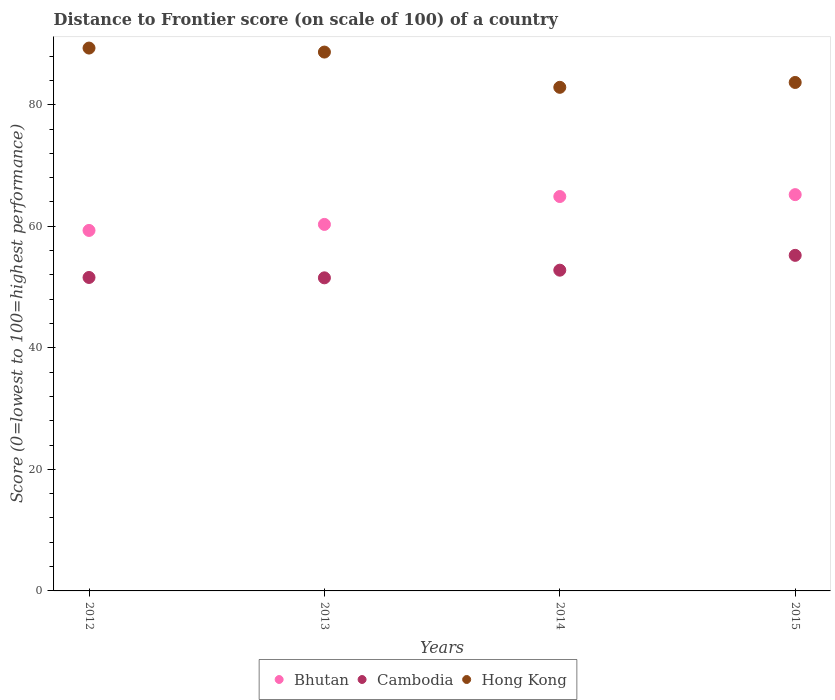Is the number of dotlines equal to the number of legend labels?
Your answer should be very brief. Yes. What is the distance to frontier score of in Bhutan in 2015?
Keep it short and to the point. 65.21. Across all years, what is the maximum distance to frontier score of in Bhutan?
Ensure brevity in your answer.  65.21. Across all years, what is the minimum distance to frontier score of in Hong Kong?
Offer a very short reply. 82.87. In which year was the distance to frontier score of in Hong Kong maximum?
Ensure brevity in your answer.  2012. What is the total distance to frontier score of in Bhutan in the graph?
Ensure brevity in your answer.  249.74. What is the difference between the distance to frontier score of in Cambodia in 2012 and that in 2015?
Provide a succinct answer. -3.64. What is the difference between the distance to frontier score of in Cambodia in 2013 and the distance to frontier score of in Hong Kong in 2012?
Make the answer very short. -37.81. What is the average distance to frontier score of in Bhutan per year?
Ensure brevity in your answer.  62.44. In the year 2014, what is the difference between the distance to frontier score of in Hong Kong and distance to frontier score of in Bhutan?
Provide a succinct answer. 17.97. What is the ratio of the distance to frontier score of in Bhutan in 2014 to that in 2015?
Offer a very short reply. 1. Is the distance to frontier score of in Cambodia in 2014 less than that in 2015?
Your answer should be very brief. Yes. What is the difference between the highest and the second highest distance to frontier score of in Bhutan?
Ensure brevity in your answer.  0.31. What is the difference between the highest and the lowest distance to frontier score of in Cambodia?
Make the answer very short. 3.7. In how many years, is the distance to frontier score of in Cambodia greater than the average distance to frontier score of in Cambodia taken over all years?
Your response must be concise. 2. Does the distance to frontier score of in Bhutan monotonically increase over the years?
Your answer should be compact. Yes. How many years are there in the graph?
Give a very brief answer. 4. What is the difference between two consecutive major ticks on the Y-axis?
Offer a terse response. 20. Does the graph contain any zero values?
Give a very brief answer. No. How many legend labels are there?
Your answer should be compact. 3. How are the legend labels stacked?
Provide a short and direct response. Horizontal. What is the title of the graph?
Provide a short and direct response. Distance to Frontier score (on scale of 100) of a country. What is the label or title of the Y-axis?
Offer a very short reply. Score (0=lowest to 100=highest performance). What is the Score (0=lowest to 100=highest performance) of Bhutan in 2012?
Provide a succinct answer. 59.32. What is the Score (0=lowest to 100=highest performance) in Cambodia in 2012?
Make the answer very short. 51.58. What is the Score (0=lowest to 100=highest performance) in Hong Kong in 2012?
Your response must be concise. 89.33. What is the Score (0=lowest to 100=highest performance) in Bhutan in 2013?
Your response must be concise. 60.31. What is the Score (0=lowest to 100=highest performance) of Cambodia in 2013?
Make the answer very short. 51.52. What is the Score (0=lowest to 100=highest performance) in Hong Kong in 2013?
Make the answer very short. 88.67. What is the Score (0=lowest to 100=highest performance) in Bhutan in 2014?
Your response must be concise. 64.9. What is the Score (0=lowest to 100=highest performance) in Cambodia in 2014?
Your answer should be very brief. 52.78. What is the Score (0=lowest to 100=highest performance) in Hong Kong in 2014?
Your answer should be very brief. 82.87. What is the Score (0=lowest to 100=highest performance) of Bhutan in 2015?
Provide a succinct answer. 65.21. What is the Score (0=lowest to 100=highest performance) in Cambodia in 2015?
Offer a terse response. 55.22. What is the Score (0=lowest to 100=highest performance) of Hong Kong in 2015?
Your answer should be compact. 83.67. Across all years, what is the maximum Score (0=lowest to 100=highest performance) of Bhutan?
Offer a terse response. 65.21. Across all years, what is the maximum Score (0=lowest to 100=highest performance) of Cambodia?
Make the answer very short. 55.22. Across all years, what is the maximum Score (0=lowest to 100=highest performance) of Hong Kong?
Offer a terse response. 89.33. Across all years, what is the minimum Score (0=lowest to 100=highest performance) of Bhutan?
Keep it short and to the point. 59.32. Across all years, what is the minimum Score (0=lowest to 100=highest performance) of Cambodia?
Ensure brevity in your answer.  51.52. Across all years, what is the minimum Score (0=lowest to 100=highest performance) in Hong Kong?
Your response must be concise. 82.87. What is the total Score (0=lowest to 100=highest performance) of Bhutan in the graph?
Provide a short and direct response. 249.74. What is the total Score (0=lowest to 100=highest performance) of Cambodia in the graph?
Ensure brevity in your answer.  211.1. What is the total Score (0=lowest to 100=highest performance) in Hong Kong in the graph?
Offer a very short reply. 344.54. What is the difference between the Score (0=lowest to 100=highest performance) of Bhutan in 2012 and that in 2013?
Offer a terse response. -0.99. What is the difference between the Score (0=lowest to 100=highest performance) of Hong Kong in 2012 and that in 2013?
Ensure brevity in your answer.  0.66. What is the difference between the Score (0=lowest to 100=highest performance) in Bhutan in 2012 and that in 2014?
Your answer should be compact. -5.58. What is the difference between the Score (0=lowest to 100=highest performance) of Hong Kong in 2012 and that in 2014?
Ensure brevity in your answer.  6.46. What is the difference between the Score (0=lowest to 100=highest performance) of Bhutan in 2012 and that in 2015?
Provide a succinct answer. -5.89. What is the difference between the Score (0=lowest to 100=highest performance) of Cambodia in 2012 and that in 2015?
Give a very brief answer. -3.64. What is the difference between the Score (0=lowest to 100=highest performance) in Hong Kong in 2012 and that in 2015?
Your answer should be compact. 5.66. What is the difference between the Score (0=lowest to 100=highest performance) in Bhutan in 2013 and that in 2014?
Your answer should be very brief. -4.59. What is the difference between the Score (0=lowest to 100=highest performance) of Cambodia in 2013 and that in 2014?
Offer a terse response. -1.26. What is the difference between the Score (0=lowest to 100=highest performance) in Cambodia in 2013 and that in 2015?
Keep it short and to the point. -3.7. What is the difference between the Score (0=lowest to 100=highest performance) of Bhutan in 2014 and that in 2015?
Provide a short and direct response. -0.31. What is the difference between the Score (0=lowest to 100=highest performance) of Cambodia in 2014 and that in 2015?
Offer a terse response. -2.44. What is the difference between the Score (0=lowest to 100=highest performance) in Hong Kong in 2014 and that in 2015?
Provide a short and direct response. -0.8. What is the difference between the Score (0=lowest to 100=highest performance) in Bhutan in 2012 and the Score (0=lowest to 100=highest performance) in Hong Kong in 2013?
Give a very brief answer. -29.35. What is the difference between the Score (0=lowest to 100=highest performance) of Cambodia in 2012 and the Score (0=lowest to 100=highest performance) of Hong Kong in 2013?
Your answer should be very brief. -37.09. What is the difference between the Score (0=lowest to 100=highest performance) in Bhutan in 2012 and the Score (0=lowest to 100=highest performance) in Cambodia in 2014?
Make the answer very short. 6.54. What is the difference between the Score (0=lowest to 100=highest performance) in Bhutan in 2012 and the Score (0=lowest to 100=highest performance) in Hong Kong in 2014?
Provide a succinct answer. -23.55. What is the difference between the Score (0=lowest to 100=highest performance) of Cambodia in 2012 and the Score (0=lowest to 100=highest performance) of Hong Kong in 2014?
Keep it short and to the point. -31.29. What is the difference between the Score (0=lowest to 100=highest performance) of Bhutan in 2012 and the Score (0=lowest to 100=highest performance) of Hong Kong in 2015?
Keep it short and to the point. -24.35. What is the difference between the Score (0=lowest to 100=highest performance) in Cambodia in 2012 and the Score (0=lowest to 100=highest performance) in Hong Kong in 2015?
Your response must be concise. -32.09. What is the difference between the Score (0=lowest to 100=highest performance) in Bhutan in 2013 and the Score (0=lowest to 100=highest performance) in Cambodia in 2014?
Make the answer very short. 7.53. What is the difference between the Score (0=lowest to 100=highest performance) in Bhutan in 2013 and the Score (0=lowest to 100=highest performance) in Hong Kong in 2014?
Offer a very short reply. -22.56. What is the difference between the Score (0=lowest to 100=highest performance) of Cambodia in 2013 and the Score (0=lowest to 100=highest performance) of Hong Kong in 2014?
Keep it short and to the point. -31.35. What is the difference between the Score (0=lowest to 100=highest performance) of Bhutan in 2013 and the Score (0=lowest to 100=highest performance) of Cambodia in 2015?
Keep it short and to the point. 5.09. What is the difference between the Score (0=lowest to 100=highest performance) in Bhutan in 2013 and the Score (0=lowest to 100=highest performance) in Hong Kong in 2015?
Offer a terse response. -23.36. What is the difference between the Score (0=lowest to 100=highest performance) of Cambodia in 2013 and the Score (0=lowest to 100=highest performance) of Hong Kong in 2015?
Your answer should be compact. -32.15. What is the difference between the Score (0=lowest to 100=highest performance) in Bhutan in 2014 and the Score (0=lowest to 100=highest performance) in Cambodia in 2015?
Provide a short and direct response. 9.68. What is the difference between the Score (0=lowest to 100=highest performance) in Bhutan in 2014 and the Score (0=lowest to 100=highest performance) in Hong Kong in 2015?
Your response must be concise. -18.77. What is the difference between the Score (0=lowest to 100=highest performance) of Cambodia in 2014 and the Score (0=lowest to 100=highest performance) of Hong Kong in 2015?
Offer a very short reply. -30.89. What is the average Score (0=lowest to 100=highest performance) of Bhutan per year?
Give a very brief answer. 62.44. What is the average Score (0=lowest to 100=highest performance) of Cambodia per year?
Offer a very short reply. 52.77. What is the average Score (0=lowest to 100=highest performance) in Hong Kong per year?
Provide a succinct answer. 86.14. In the year 2012, what is the difference between the Score (0=lowest to 100=highest performance) in Bhutan and Score (0=lowest to 100=highest performance) in Cambodia?
Give a very brief answer. 7.74. In the year 2012, what is the difference between the Score (0=lowest to 100=highest performance) in Bhutan and Score (0=lowest to 100=highest performance) in Hong Kong?
Provide a succinct answer. -30.01. In the year 2012, what is the difference between the Score (0=lowest to 100=highest performance) of Cambodia and Score (0=lowest to 100=highest performance) of Hong Kong?
Offer a terse response. -37.75. In the year 2013, what is the difference between the Score (0=lowest to 100=highest performance) of Bhutan and Score (0=lowest to 100=highest performance) of Cambodia?
Your response must be concise. 8.79. In the year 2013, what is the difference between the Score (0=lowest to 100=highest performance) in Bhutan and Score (0=lowest to 100=highest performance) in Hong Kong?
Provide a short and direct response. -28.36. In the year 2013, what is the difference between the Score (0=lowest to 100=highest performance) in Cambodia and Score (0=lowest to 100=highest performance) in Hong Kong?
Offer a terse response. -37.15. In the year 2014, what is the difference between the Score (0=lowest to 100=highest performance) in Bhutan and Score (0=lowest to 100=highest performance) in Cambodia?
Your answer should be compact. 12.12. In the year 2014, what is the difference between the Score (0=lowest to 100=highest performance) in Bhutan and Score (0=lowest to 100=highest performance) in Hong Kong?
Ensure brevity in your answer.  -17.97. In the year 2014, what is the difference between the Score (0=lowest to 100=highest performance) in Cambodia and Score (0=lowest to 100=highest performance) in Hong Kong?
Your response must be concise. -30.09. In the year 2015, what is the difference between the Score (0=lowest to 100=highest performance) in Bhutan and Score (0=lowest to 100=highest performance) in Cambodia?
Provide a succinct answer. 9.99. In the year 2015, what is the difference between the Score (0=lowest to 100=highest performance) of Bhutan and Score (0=lowest to 100=highest performance) of Hong Kong?
Make the answer very short. -18.46. In the year 2015, what is the difference between the Score (0=lowest to 100=highest performance) in Cambodia and Score (0=lowest to 100=highest performance) in Hong Kong?
Ensure brevity in your answer.  -28.45. What is the ratio of the Score (0=lowest to 100=highest performance) of Bhutan in 2012 to that in 2013?
Provide a short and direct response. 0.98. What is the ratio of the Score (0=lowest to 100=highest performance) in Cambodia in 2012 to that in 2013?
Keep it short and to the point. 1. What is the ratio of the Score (0=lowest to 100=highest performance) of Hong Kong in 2012 to that in 2013?
Provide a succinct answer. 1.01. What is the ratio of the Score (0=lowest to 100=highest performance) of Bhutan in 2012 to that in 2014?
Provide a succinct answer. 0.91. What is the ratio of the Score (0=lowest to 100=highest performance) of Cambodia in 2012 to that in 2014?
Keep it short and to the point. 0.98. What is the ratio of the Score (0=lowest to 100=highest performance) of Hong Kong in 2012 to that in 2014?
Give a very brief answer. 1.08. What is the ratio of the Score (0=lowest to 100=highest performance) in Bhutan in 2012 to that in 2015?
Ensure brevity in your answer.  0.91. What is the ratio of the Score (0=lowest to 100=highest performance) in Cambodia in 2012 to that in 2015?
Your answer should be compact. 0.93. What is the ratio of the Score (0=lowest to 100=highest performance) in Hong Kong in 2012 to that in 2015?
Provide a short and direct response. 1.07. What is the ratio of the Score (0=lowest to 100=highest performance) of Bhutan in 2013 to that in 2014?
Offer a very short reply. 0.93. What is the ratio of the Score (0=lowest to 100=highest performance) of Cambodia in 2013 to that in 2014?
Your response must be concise. 0.98. What is the ratio of the Score (0=lowest to 100=highest performance) of Hong Kong in 2013 to that in 2014?
Offer a very short reply. 1.07. What is the ratio of the Score (0=lowest to 100=highest performance) in Bhutan in 2013 to that in 2015?
Give a very brief answer. 0.92. What is the ratio of the Score (0=lowest to 100=highest performance) in Cambodia in 2013 to that in 2015?
Make the answer very short. 0.93. What is the ratio of the Score (0=lowest to 100=highest performance) in Hong Kong in 2013 to that in 2015?
Offer a very short reply. 1.06. What is the ratio of the Score (0=lowest to 100=highest performance) in Cambodia in 2014 to that in 2015?
Make the answer very short. 0.96. What is the difference between the highest and the second highest Score (0=lowest to 100=highest performance) in Bhutan?
Offer a very short reply. 0.31. What is the difference between the highest and the second highest Score (0=lowest to 100=highest performance) in Cambodia?
Make the answer very short. 2.44. What is the difference between the highest and the second highest Score (0=lowest to 100=highest performance) in Hong Kong?
Give a very brief answer. 0.66. What is the difference between the highest and the lowest Score (0=lowest to 100=highest performance) in Bhutan?
Provide a succinct answer. 5.89. What is the difference between the highest and the lowest Score (0=lowest to 100=highest performance) in Cambodia?
Offer a terse response. 3.7. What is the difference between the highest and the lowest Score (0=lowest to 100=highest performance) of Hong Kong?
Provide a short and direct response. 6.46. 